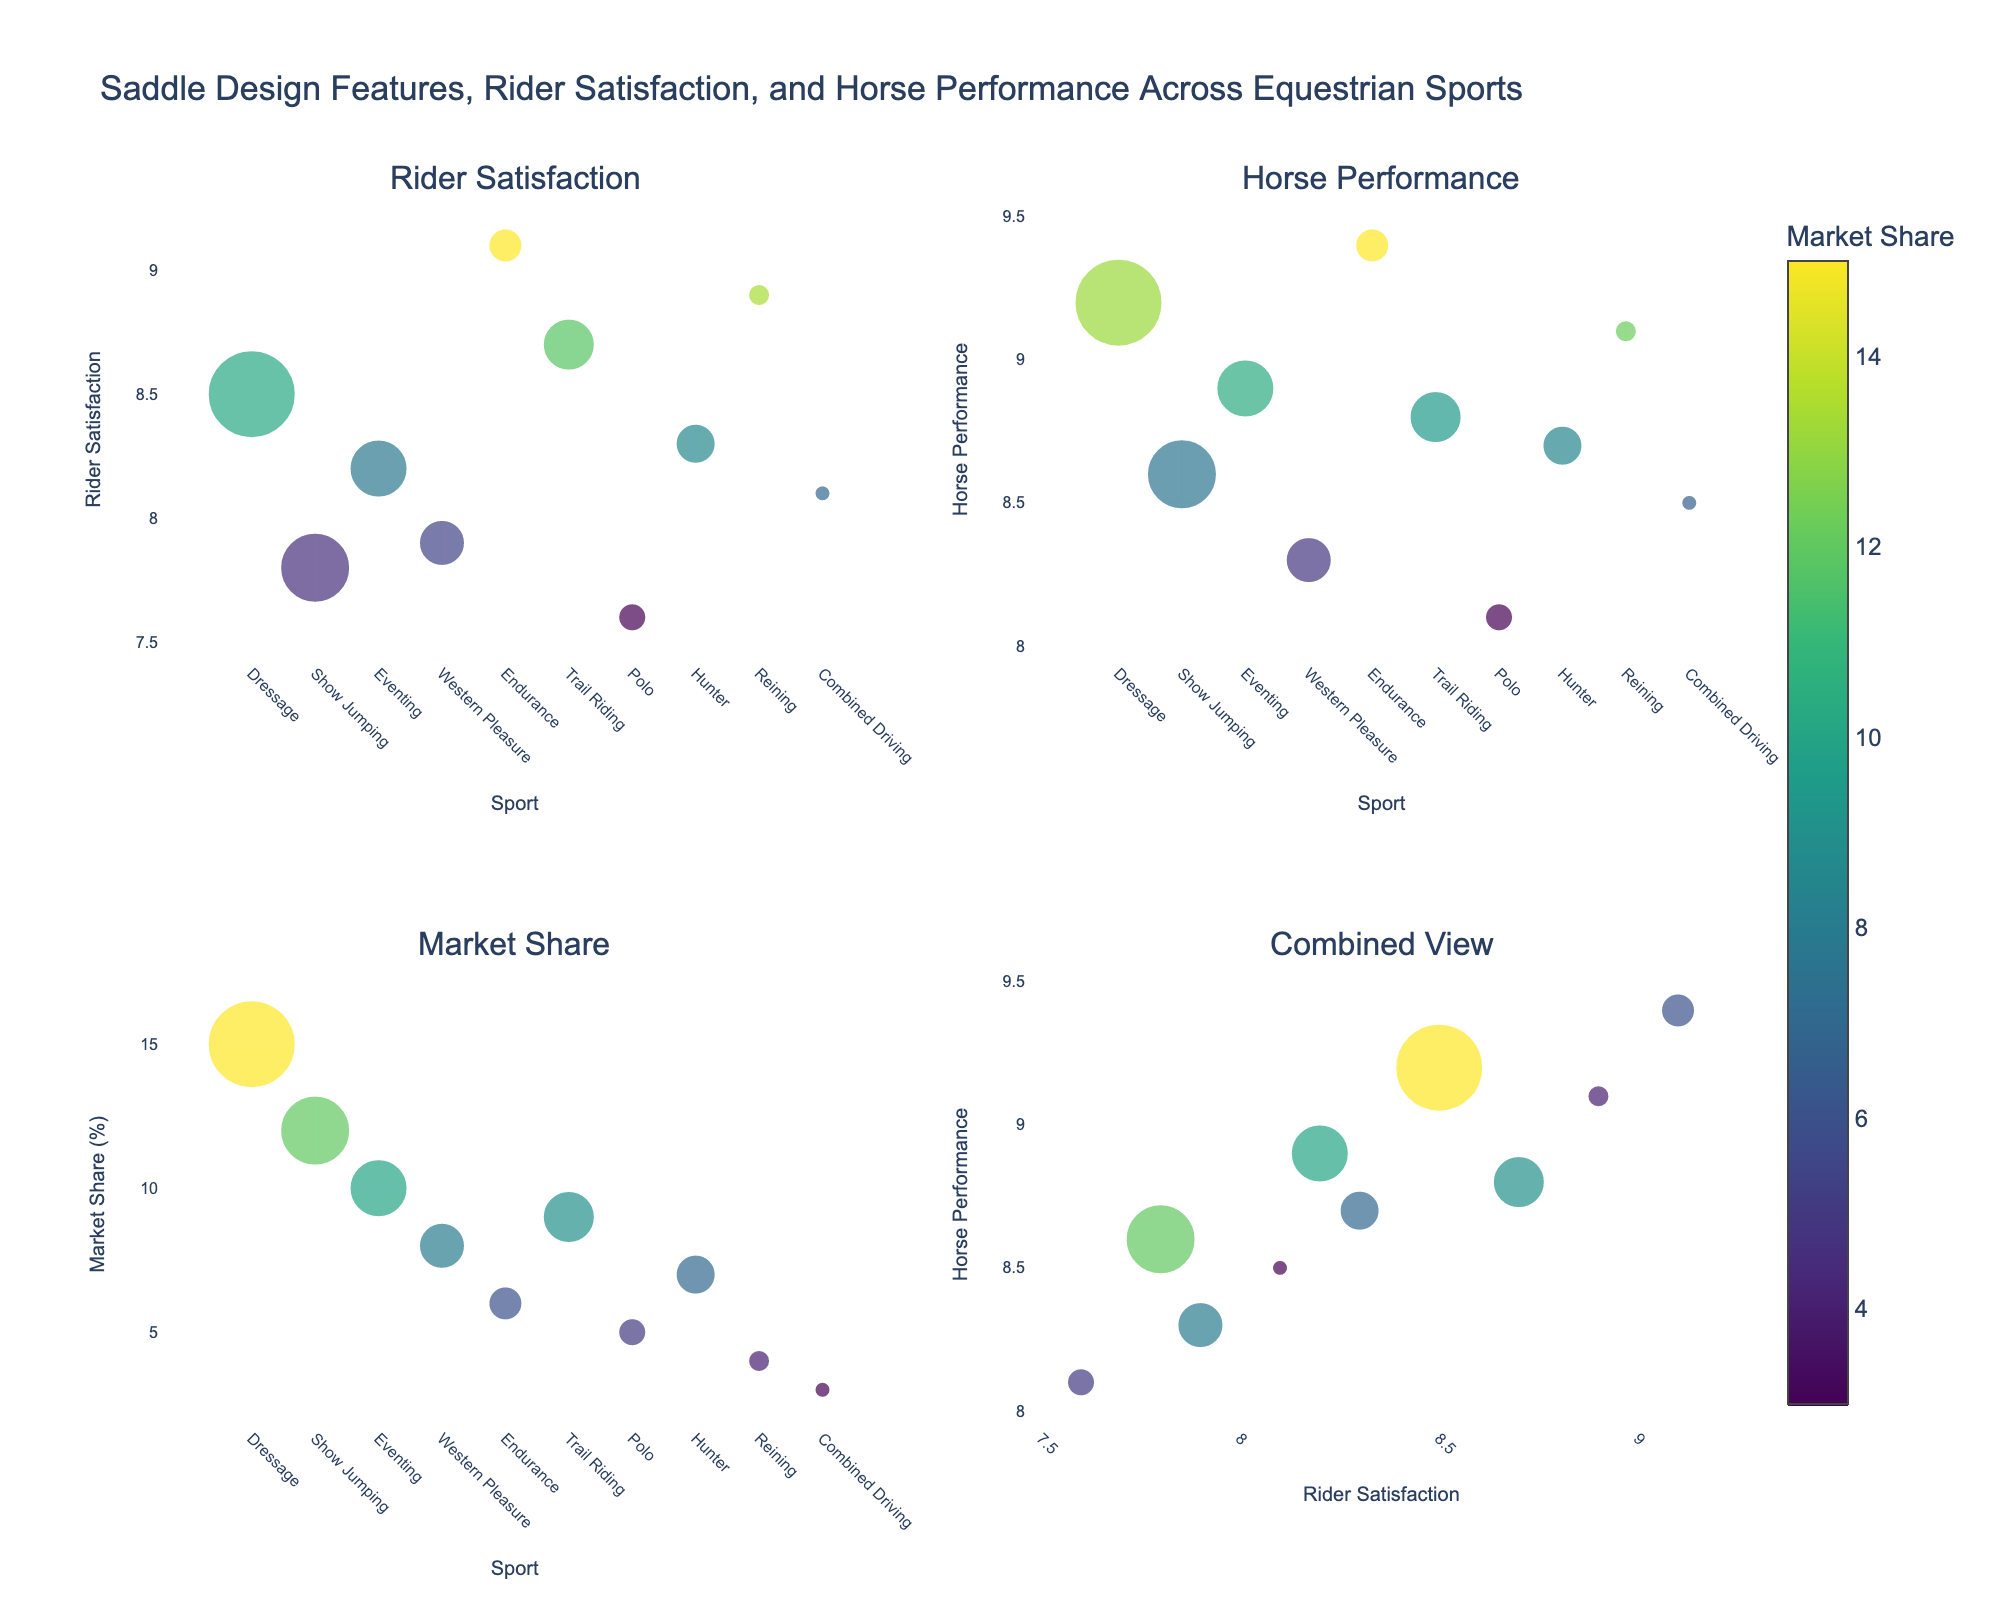How are the subplots organized in this figure? The figure contains four subplots arranged in a 2x2 grid. The titles are "Rider Satisfaction," "Horse Performance," "Market Share," and "Combined View." The x-axes generally indicate the "Sport," except for the combined view, which uses "Rider Satisfaction." The y-axes are "Rider Satisfaction," "Horse Performance," "Market Share (%)," and "Horse Performance," respectively.
Answer: 2x2 grid: Rider Satisfaction, Horse Performance, Market Share, Combined View Which sport has the highest rider satisfaction score, and what saddle feature is associated with it? In the subplot titled "Rider Satisfaction," the highest y-value is for "Endurance," scoring 9.1. The associated saddle feature for Endurance is "Lightweight Design."
Answer: Endurance, "Lightweight Design" Compare the market share for Dressage and Polo. Which sport has a higher market share and by how much? From the subplot titled "Market Share," Dressage has a market share bubble about 15, whereas Polo has a market share bubble about 5. The difference is 10 (%).
Answer: Dressage, 10% Which equestrian sport scored highest in the combined view for horse performance, and what is its corresponding rider satisfaction score? In the subplot titled "Combined View," the highest y-value for horse performance is Dressage with a score of 9.2. Its corresponding rider satisfaction score is 8.5.
Answer: Dressage, 8.5 Identify the sport with the lowest horse performance score and state its saddle feature. In the subplot titled "Horse Performance," the lowest y-value is for Polo, with a score of 8.1. The saddle feature for Polo is "Close Contact."
Answer: Polo, "Close Contact" Which sport has the largest bubble in the combined view, indicating it has the highest market share? In the subplot titled "Combined View," the largest bubble in size belongs to Dressage, indicating it has the highest market share.
Answer: Dressage What is the average horse performance score across all equestrian sports? Add all the horse performance scores across the sports (9.2 + 8.6 + 8.9 + 8.3 + 9.4 + 8.8 + 8.1 + 8.7 + 9.1 + 8.5) = 87.6, then divide by the number of sports, which is 10. So, the average is 87.6/10 = 8.76.
Answer: 8.76 Which saddle design feature has the smallest market share and what sport is it associated with? In the subplot titled "Market Share," the smallest bubble size is for Combined Driving, indicating a market share of about 3. Its saddle feature is "Air-Cushioned Panels."
Answer: "Air-Cushioned Panels," Combined Driving 